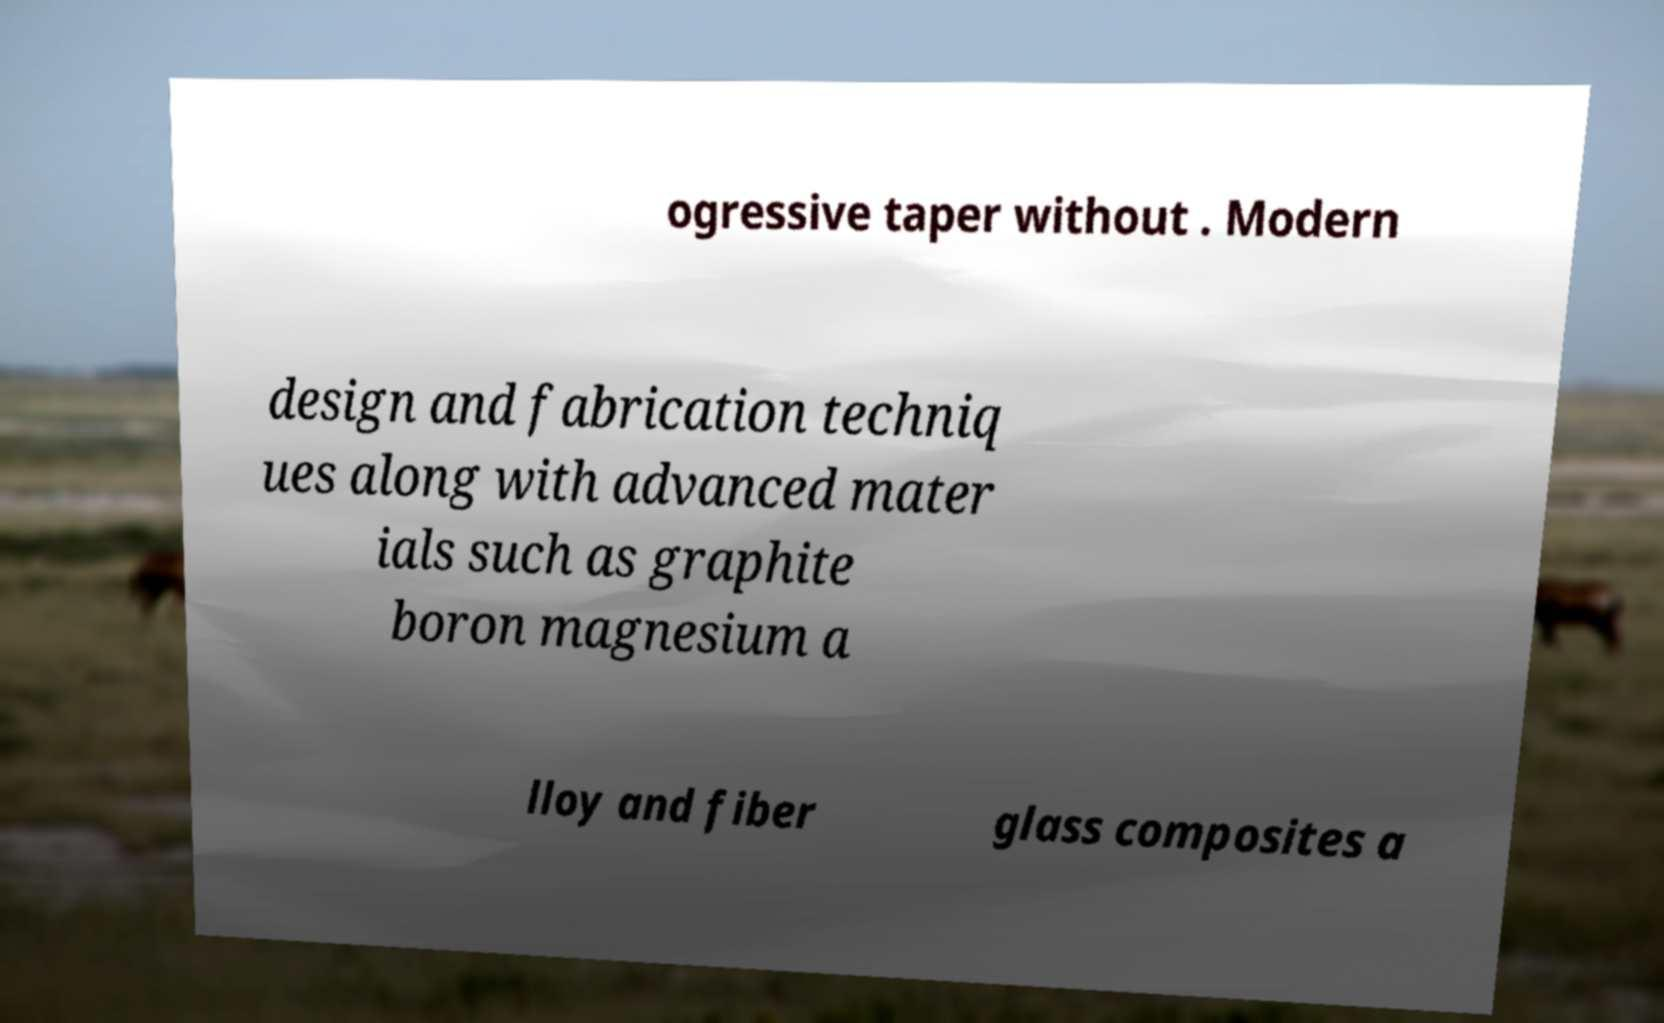There's text embedded in this image that I need extracted. Can you transcribe it verbatim? ogressive taper without . Modern design and fabrication techniq ues along with advanced mater ials such as graphite boron magnesium a lloy and fiber glass composites a 